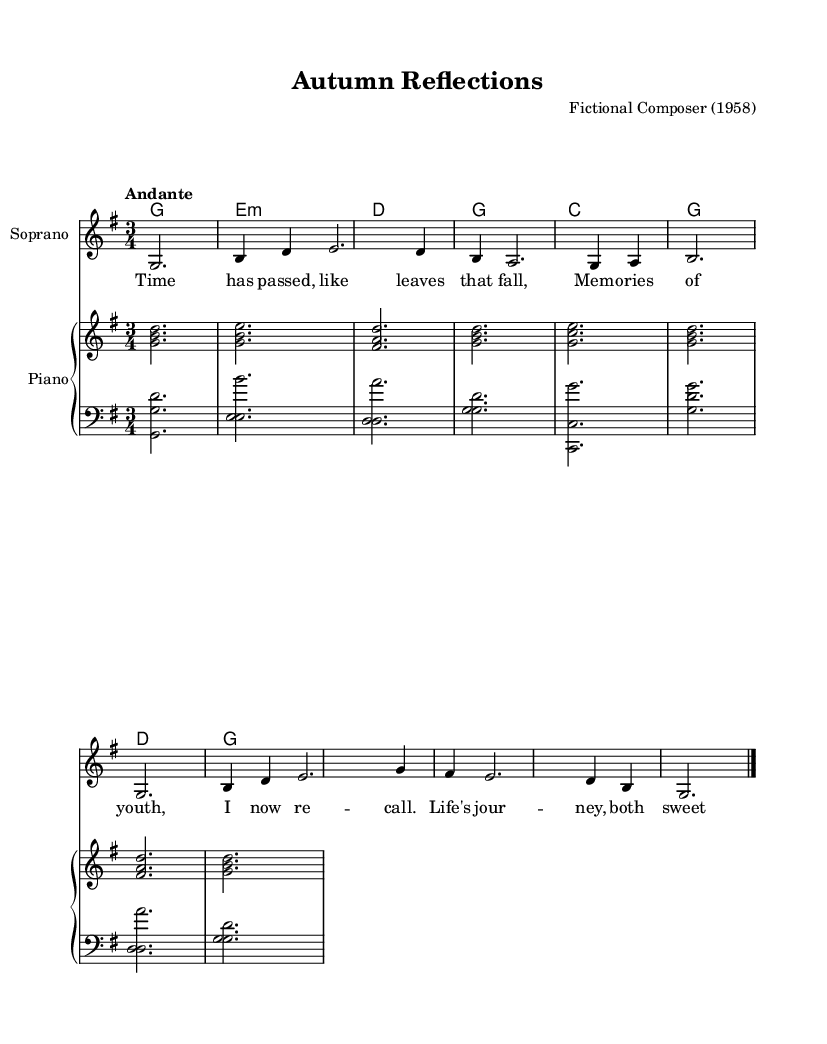What is the key signature of this music? The key signature is G major, which has one sharp. This is indicated at the beginning of the staff.
Answer: G major What is the time signature of the piece? The time signature is 3/4, which means there are three beats in a measure. This is shown at the beginning of the score, next to the key signature.
Answer: 3/4 What is the tempo marking of this piece? The tempo marking is "Andante," which suggests a moderate pace. This can be found as a descriptive term at the beginning of the music.
Answer: Andante How many measures are in the melody? The melody has 8 measures, which can be counted by identifying the vertical lines that indicate the end of each measure throughout the staff.
Answer: 8 What type of lyrics are present in this piece? The lyrics are reflective and nostalgic, discussing memories and life's journey, as indicated by the text aligned with the melody.
Answer: Reflective What is the structure type of this piece of music? The structure type is opera, which is supported by the lyrical content and the dramatic presentation typical of operatic music.
Answer: Opera What instrument plays the melody? The melody is played by a soprano voice, as indicated at the beginning of the staff.
Answer: Soprano 